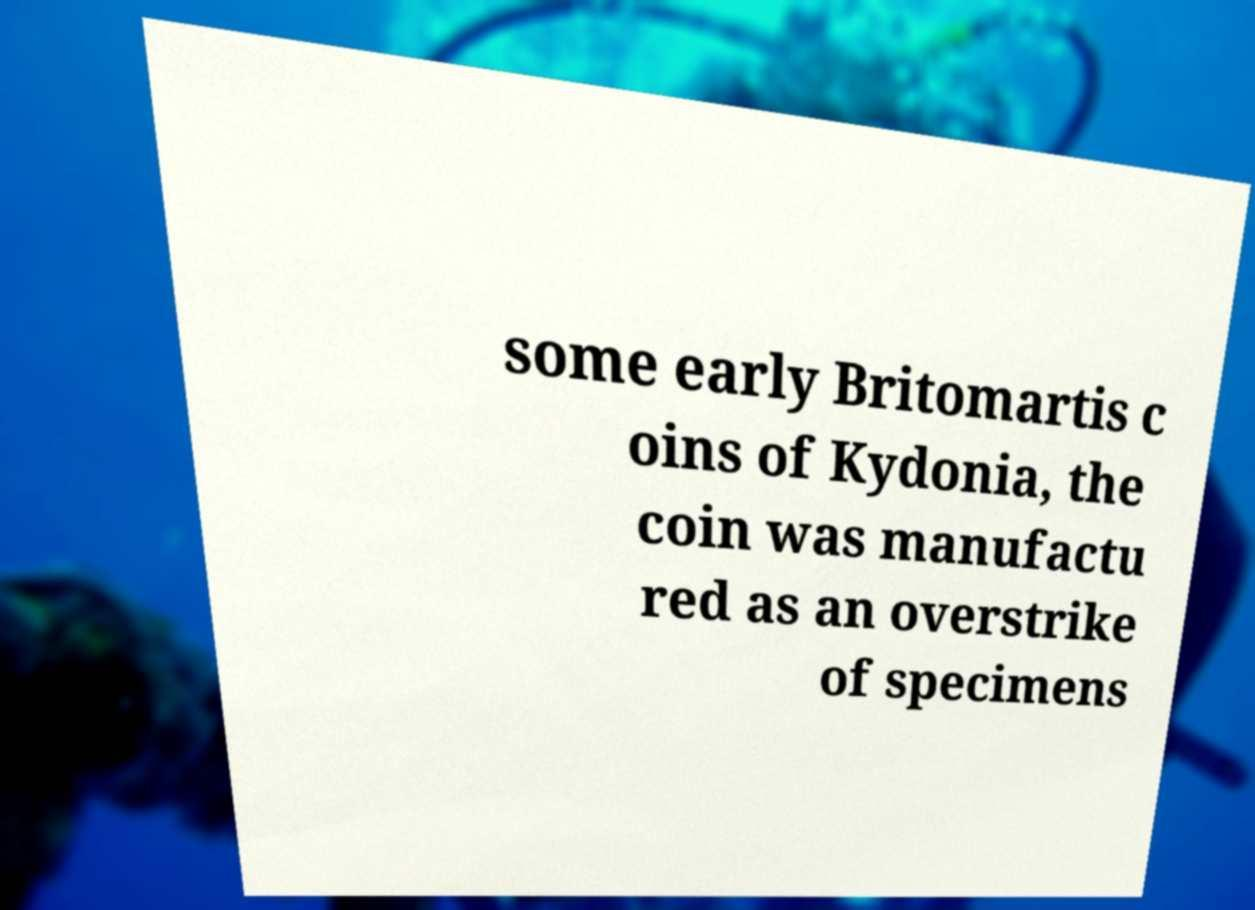There's text embedded in this image that I need extracted. Can you transcribe it verbatim? some early Britomartis c oins of Kydonia, the coin was manufactu red as an overstrike of specimens 